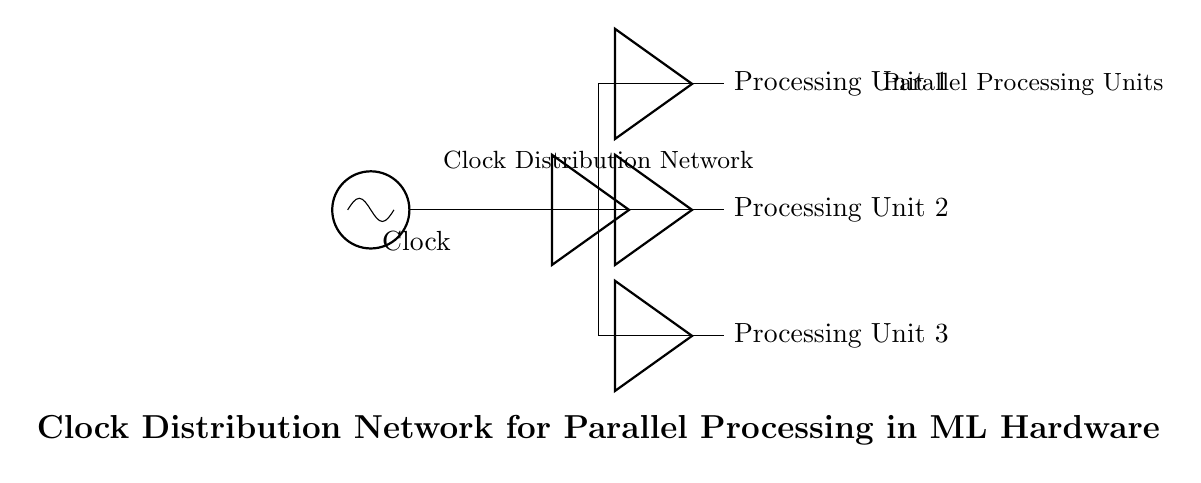What is the primary source of this circuit? The primary source of this circuit is the clock oscillator, indicated at the left of the diagram. It generates the clock signal that synchronizes the distributed signals to the processing units.
Answer: clock oscillator How many processing units are shown in the diagram? The diagram shows three processing units labeled Processing Unit 1, Processing Unit 2, and Processing Unit 3. Each unit is connected to the clock distribution network.
Answer: three What is the purpose of the buffers in the circuit? The buffers serve to strengthen the clock signal as it is distributed to each processing unit, ensuring signal integrity and reducing propagation delay.
Answer: signal integrity Which component connects the clock to the processing units? The clock distribution network connects the clock oscillator to all processing units, allowing them to receive synchronized clock pulses.
Answer: clock distribution network What is the configuration of the processing units in this circuit? The processing units are arranged in parallel, receiving the clock signal simultaneously from the distribution network. Each processing unit operates independently but synchronously.
Answer: parallel 